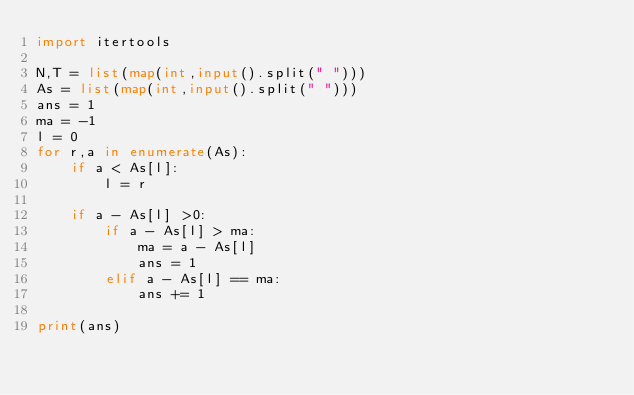Convert code to text. <code><loc_0><loc_0><loc_500><loc_500><_Python_>import itertools

N,T = list(map(int,input().split(" ")))
As = list(map(int,input().split(" ")))
ans = 1
ma = -1
l = 0
for r,a in enumerate(As):
    if a < As[l]:
        l = r

    if a - As[l] >0:
        if a - As[l] > ma:
            ma = a - As[l]
            ans = 1
        elif a - As[l] == ma:
            ans += 1

print(ans)



</code> 